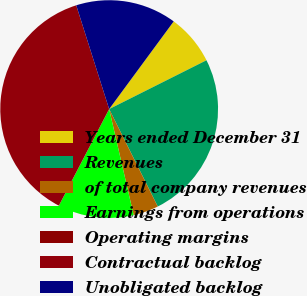<chart> <loc_0><loc_0><loc_500><loc_500><pie_chart><fcel>Years ended December 31<fcel>Revenues<fcel>of total company revenues<fcel>Earnings from operations<fcel>Operating margins<fcel>Contractual backlog<fcel>Unobligated backlog<nl><fcel>7.5%<fcel>25.04%<fcel>3.75%<fcel>11.25%<fcel>0.01%<fcel>37.47%<fcel>14.99%<nl></chart> 